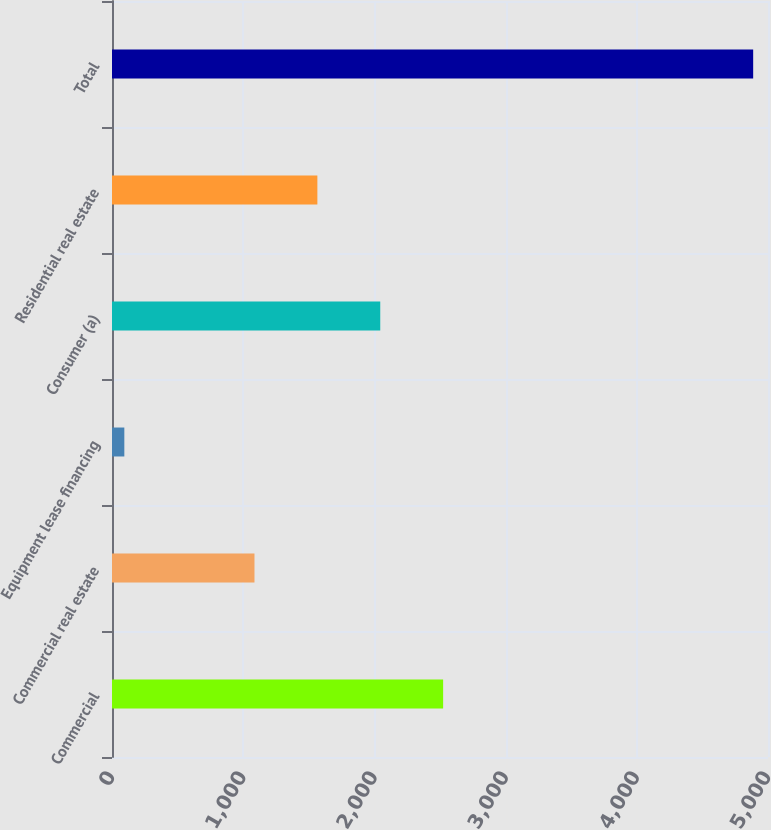<chart> <loc_0><loc_0><loc_500><loc_500><bar_chart><fcel>Commercial<fcel>Commercial real estate<fcel>Equipment lease financing<fcel>Consumer (a)<fcel>Residential real estate<fcel>Total<nl><fcel>2523.9<fcel>1086<fcel>94<fcel>2044.6<fcel>1565.3<fcel>4887<nl></chart> 